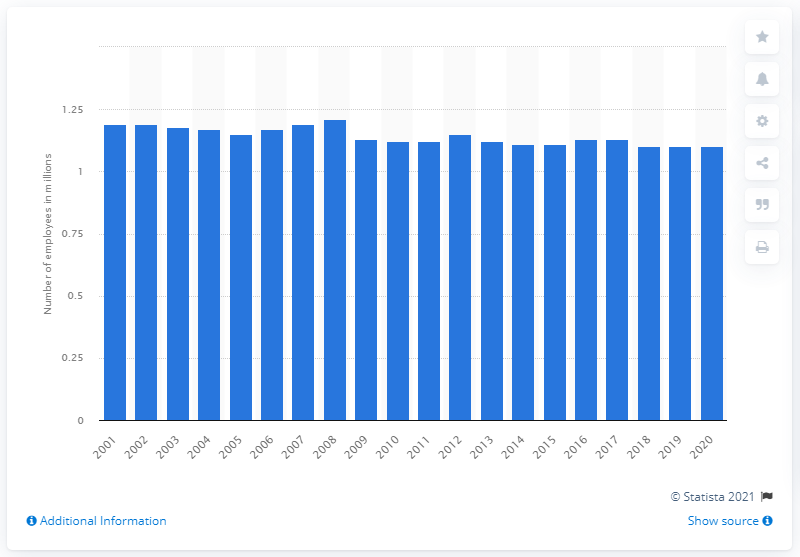List a handful of essential elements in this visual. In 2010, the financial services sector employed approximately 1.1 million people. In 2020, the total number of people employed in the financial services sector in the UK was 1,100,000. In the UK during the period of 2001-2020, a total of 1.21 million people were employed in all subsectors of financial services. 